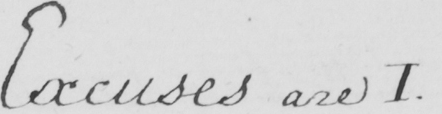Can you read and transcribe this handwriting? Excuses are I . 